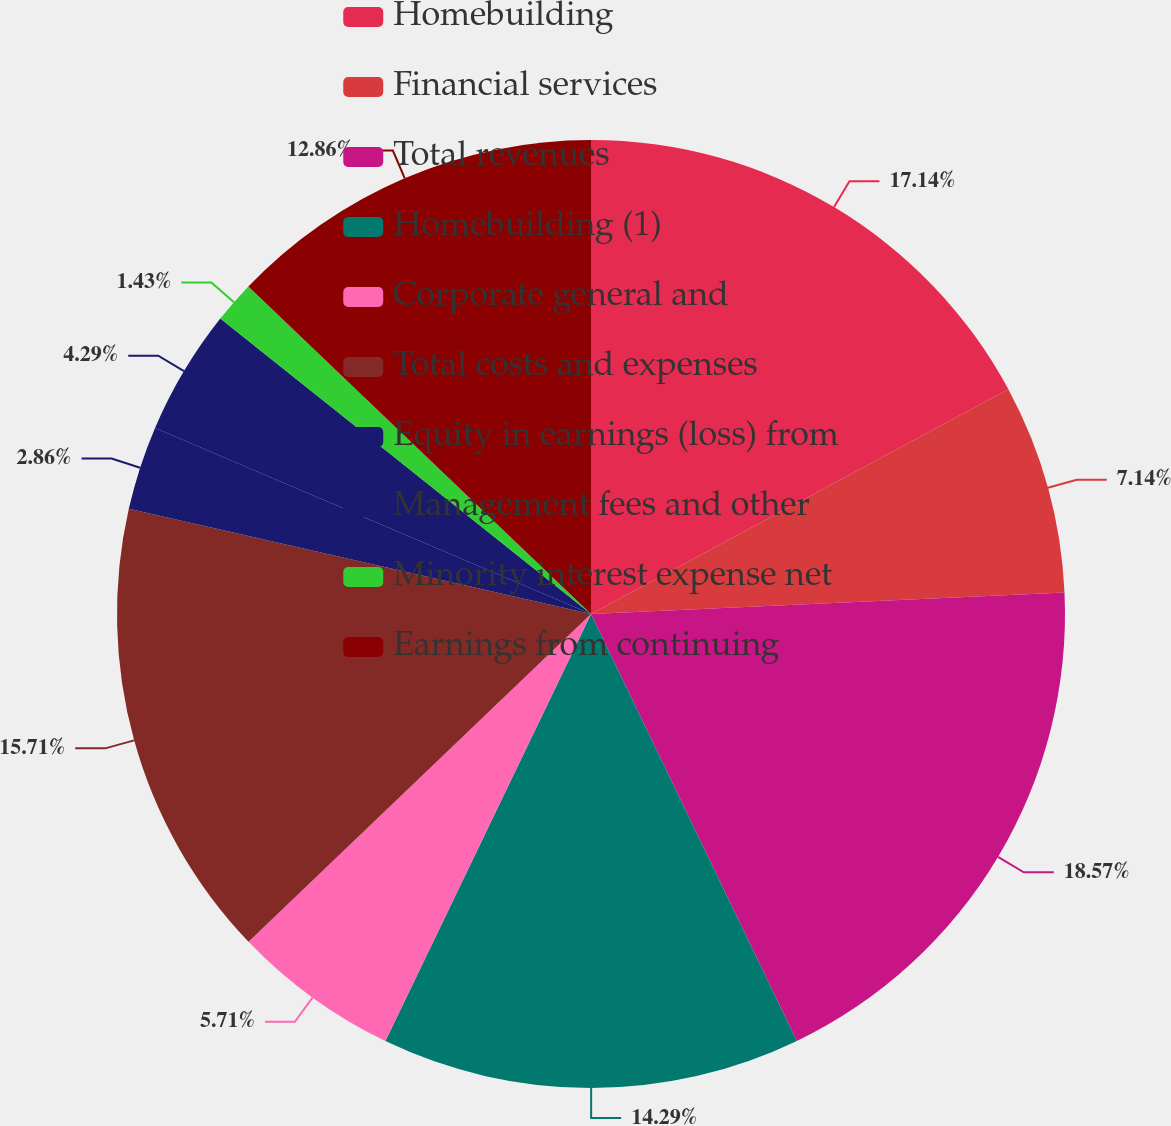<chart> <loc_0><loc_0><loc_500><loc_500><pie_chart><fcel>Homebuilding<fcel>Financial services<fcel>Total revenues<fcel>Homebuilding (1)<fcel>Corporate general and<fcel>Total costs and expenses<fcel>Equity in earnings (loss) from<fcel>Management fees and other<fcel>Minority interest expense net<fcel>Earnings from continuing<nl><fcel>17.14%<fcel>7.14%<fcel>18.57%<fcel>14.29%<fcel>5.71%<fcel>15.71%<fcel>2.86%<fcel>4.29%<fcel>1.43%<fcel>12.86%<nl></chart> 